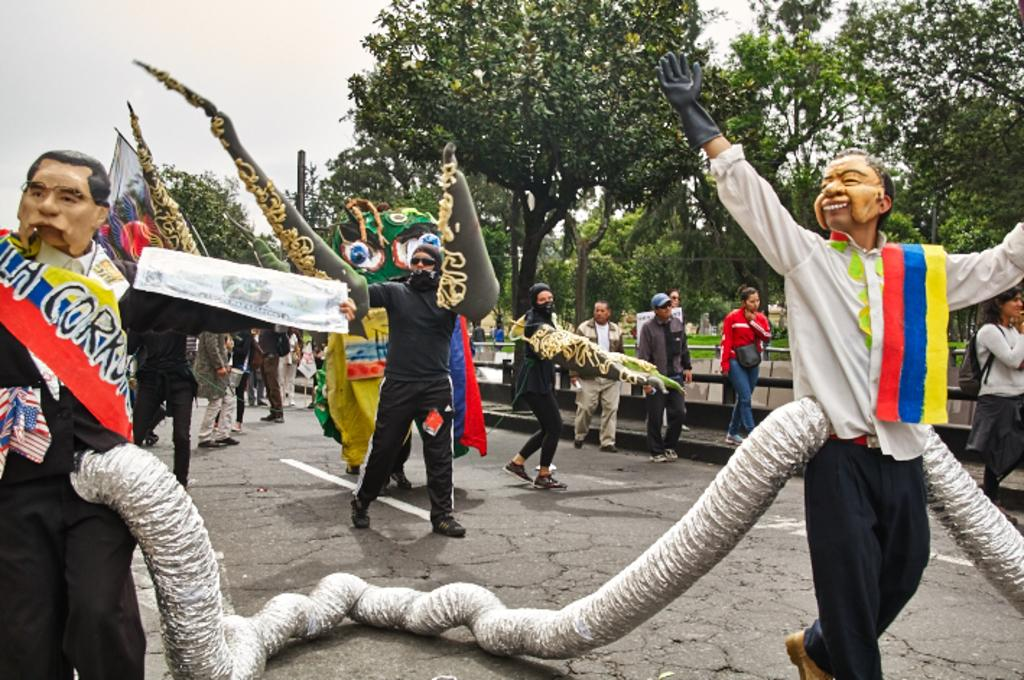What are the people in the image wearing? The people in the image are wearing costumes. What are the people in costumes doing in the image? These people are performing on the road. What can be seen in the background of the image? In the background of the image, there are people walking, trees, creeper plants, and the sky. What is the title of the book the dolls are reading in the image? There are no dolls or books present in the image. 